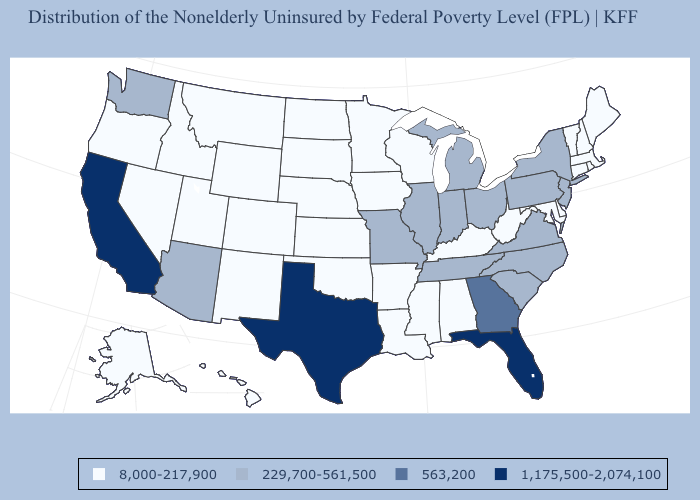What is the value of Delaware?
Quick response, please. 8,000-217,900. Which states have the lowest value in the Northeast?
Quick response, please. Connecticut, Maine, Massachusetts, New Hampshire, Rhode Island, Vermont. What is the value of New York?
Concise answer only. 229,700-561,500. What is the lowest value in states that border Mississippi?
Keep it brief. 8,000-217,900. What is the highest value in the USA?
Short answer required. 1,175,500-2,074,100. Does Ohio have the lowest value in the MidWest?
Keep it brief. No. Among the states that border Missouri , does Oklahoma have the lowest value?
Short answer required. Yes. What is the lowest value in states that border Maine?
Answer briefly. 8,000-217,900. What is the value of Arizona?
Be succinct. 229,700-561,500. What is the lowest value in states that border Delaware?
Write a very short answer. 8,000-217,900. What is the value of Alabama?
Give a very brief answer. 8,000-217,900. Is the legend a continuous bar?
Give a very brief answer. No. Name the states that have a value in the range 563,200?
Give a very brief answer. Georgia. What is the lowest value in the MidWest?
Quick response, please. 8,000-217,900. Which states have the lowest value in the Northeast?
Answer briefly. Connecticut, Maine, Massachusetts, New Hampshire, Rhode Island, Vermont. 